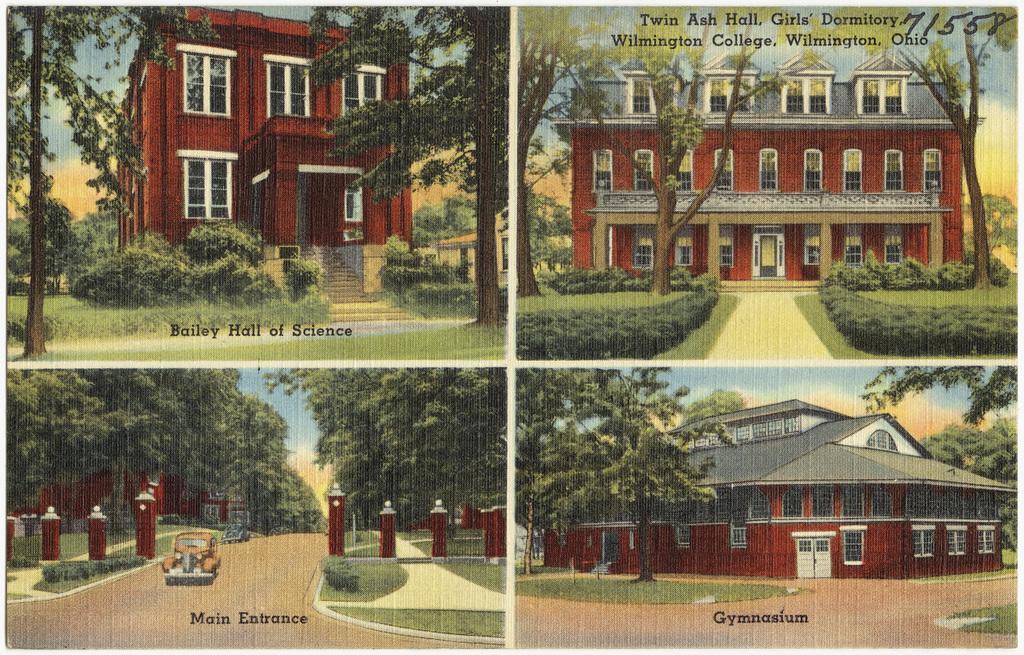In one or two sentences, can you explain what this image depicts? In this image we can see the collage picture of buildings, trees, pillars, grass, sky and vehicle on the road. And there is the text written on the picture. 